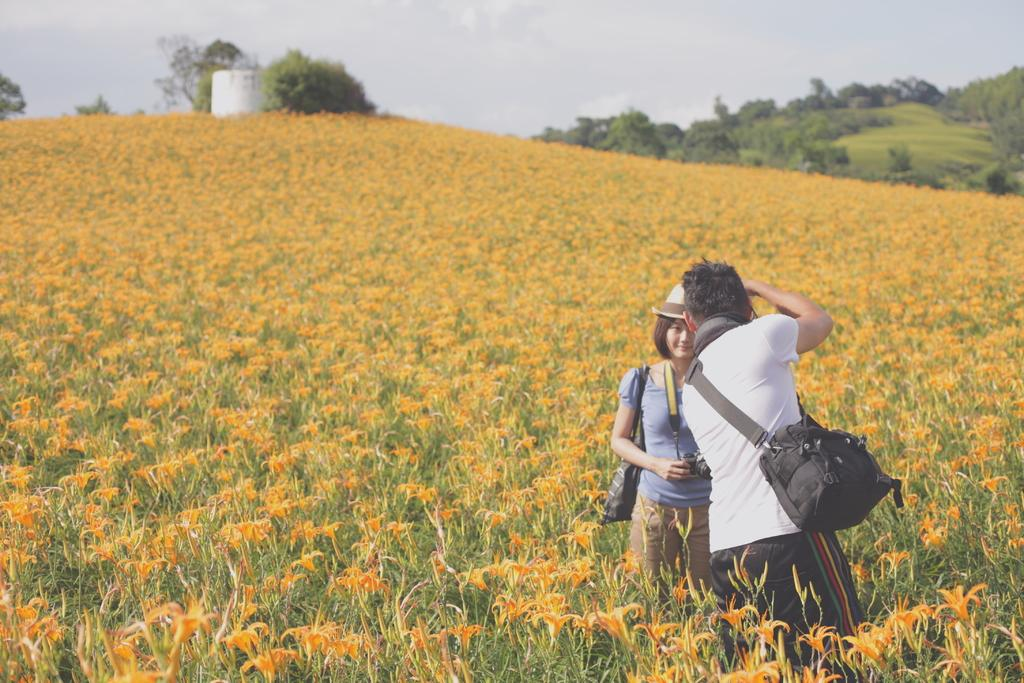How many people are in the image? There are two people in the image, a man and a girl. What are the man and the girl doing in the image? The man is facing backward, and both the man and the girl are standing. What are they wearing? They are wearing clothes. What are they carrying? They are carrying bags. What can be seen in the background of the image? There are flower plants, trees, and the sky visible in the image. What type of prose can be heard being read aloud in the image? There is no indication in the image that any prose is being read aloud. What is the scale of the trees in the image? The scale of the trees cannot be determined from the image alone, as there is no reference point for comparison. 